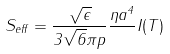<formula> <loc_0><loc_0><loc_500><loc_500>S _ { e f f } = \frac { \sqrt { \epsilon } } { 3 \sqrt { 6 } \pi p } \frac { \eta a ^ { 4 } } { } I ( T )</formula> 